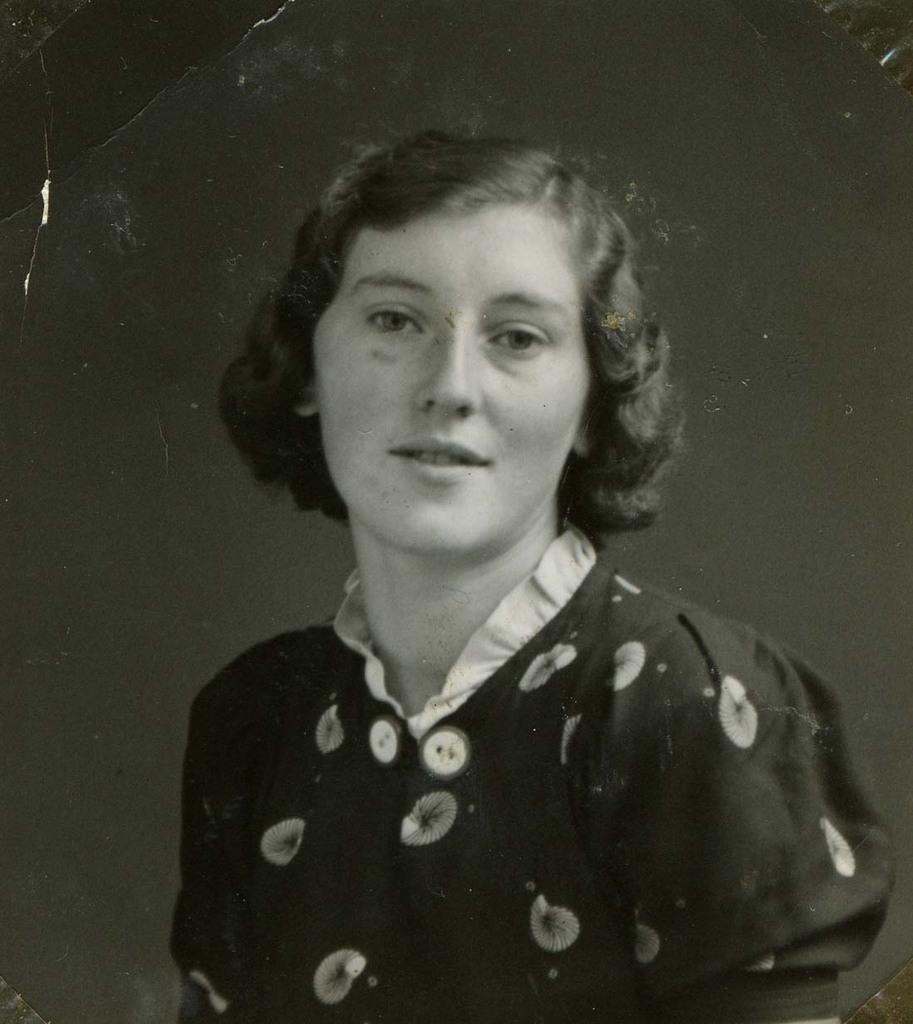Could you give a brief overview of what you see in this image? This picture is in black and white. In the center, there is a woman. 